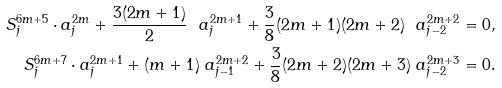<formula> <loc_0><loc_0><loc_500><loc_500>S ^ { 6 m + 5 } _ { j } \cdot a _ { j } ^ { 2 m } + \frac { 3 ( 2 m + 1 ) } { 2 } \ a _ { j } ^ { 2 m + 1 } + \frac { 3 } { 8 } ( 2 m + 1 ) ( 2 m + 2 ) \ a _ { j - 2 } ^ { 2 m + 2 } = 0 , \\ S ^ { 6 m + 7 } _ { j } \cdot a _ { j } ^ { 2 m + 1 } + ( m + 1 ) \ a _ { j - 1 } ^ { 2 m + 2 } + \frac { 3 } { 8 } ( 2 m + 2 ) ( 2 m + 3 ) \ a _ { j - 2 } ^ { 2 m + 3 } = 0 .</formula> 